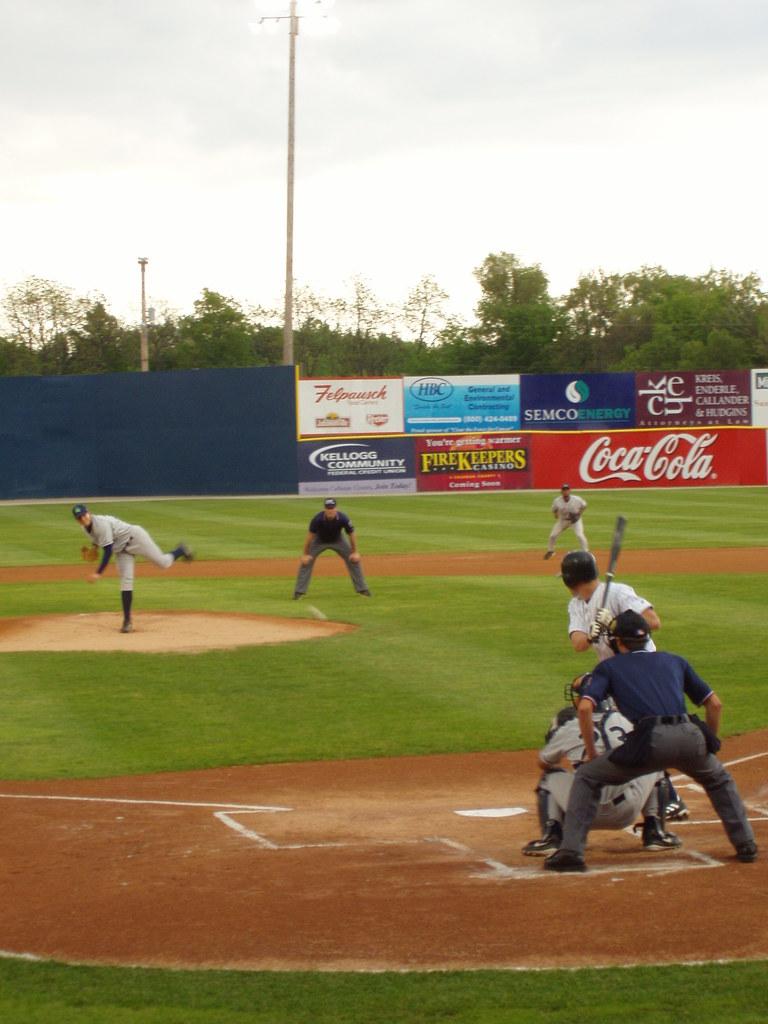Does coke sponsor this event?
Your response must be concise. Yes. What company has the top blue banner?
Provide a short and direct response. Semco. 